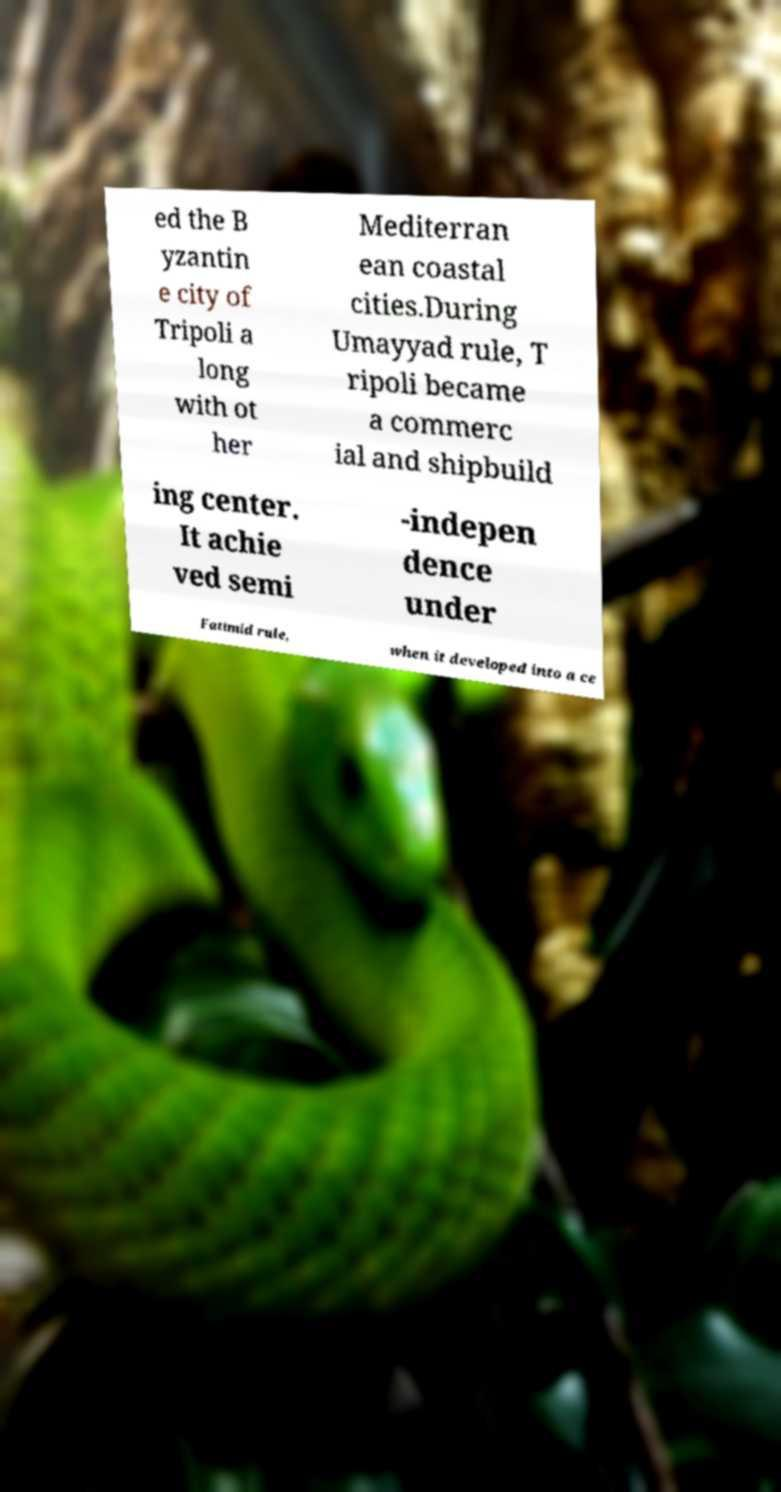There's text embedded in this image that I need extracted. Can you transcribe it verbatim? ed the B yzantin e city of Tripoli a long with ot her Mediterran ean coastal cities.During Umayyad rule, T ripoli became a commerc ial and shipbuild ing center. It achie ved semi -indepen dence under Fatimid rule, when it developed into a ce 